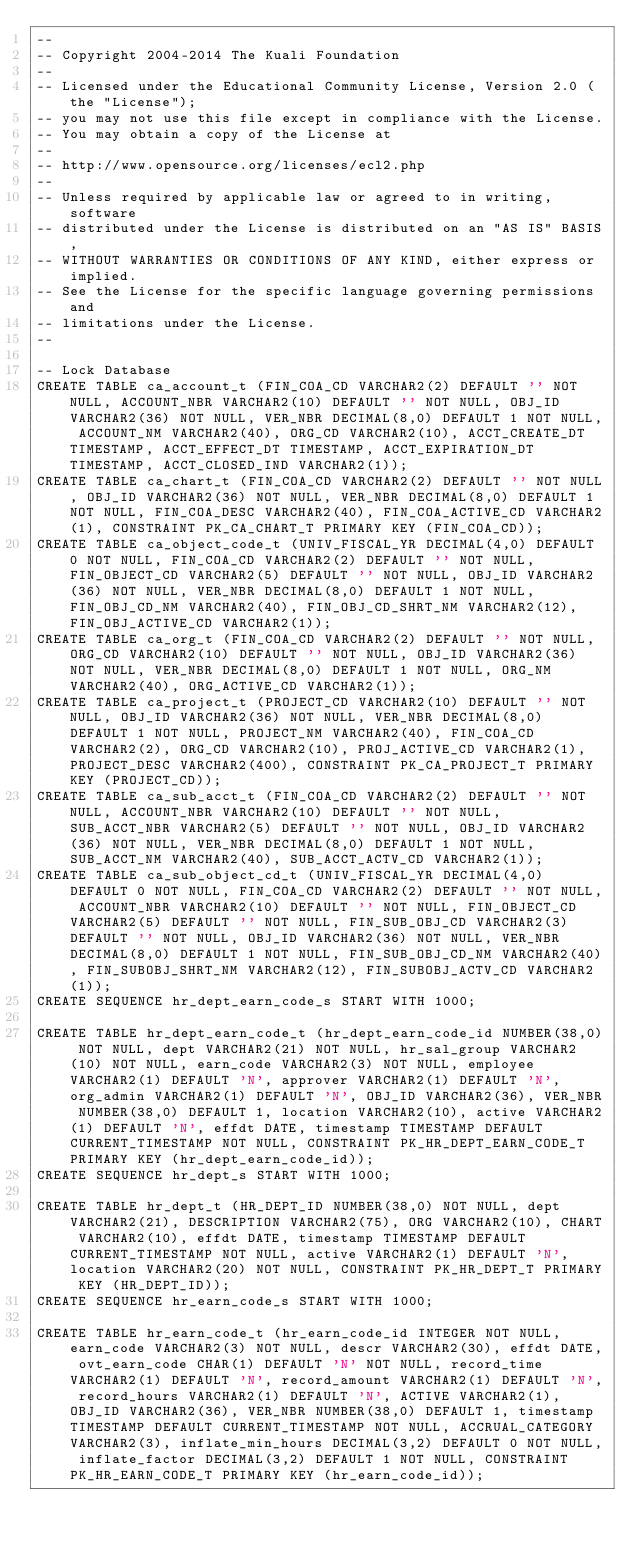<code> <loc_0><loc_0><loc_500><loc_500><_SQL_>--
-- Copyright 2004-2014 The Kuali Foundation
--
-- Licensed under the Educational Community License, Version 2.0 (the "License");
-- you may not use this file except in compliance with the License.
-- You may obtain a copy of the License at
--
-- http://www.opensource.org/licenses/ecl2.php
--
-- Unless required by applicable law or agreed to in writing, software
-- distributed under the License is distributed on an "AS IS" BASIS,
-- WITHOUT WARRANTIES OR CONDITIONS OF ANY KIND, either express or implied.
-- See the License for the specific language governing permissions and
-- limitations under the License.
--

-- Lock Database
CREATE TABLE ca_account_t (FIN_COA_CD VARCHAR2(2) DEFAULT '' NOT NULL, ACCOUNT_NBR VARCHAR2(10) DEFAULT '' NOT NULL, OBJ_ID VARCHAR2(36) NOT NULL, VER_NBR DECIMAL(8,0) DEFAULT 1 NOT NULL, ACCOUNT_NM VARCHAR2(40), ORG_CD VARCHAR2(10), ACCT_CREATE_DT TIMESTAMP, ACCT_EFFECT_DT TIMESTAMP, ACCT_EXPIRATION_DT TIMESTAMP, ACCT_CLOSED_IND VARCHAR2(1));
CREATE TABLE ca_chart_t (FIN_COA_CD VARCHAR2(2) DEFAULT '' NOT NULL, OBJ_ID VARCHAR2(36) NOT NULL, VER_NBR DECIMAL(8,0) DEFAULT 1 NOT NULL, FIN_COA_DESC VARCHAR2(40), FIN_COA_ACTIVE_CD VARCHAR2(1), CONSTRAINT PK_CA_CHART_T PRIMARY KEY (FIN_COA_CD));
CREATE TABLE ca_object_code_t (UNIV_FISCAL_YR DECIMAL(4,0) DEFAULT 0 NOT NULL, FIN_COA_CD VARCHAR2(2) DEFAULT '' NOT NULL, FIN_OBJECT_CD VARCHAR2(5) DEFAULT '' NOT NULL, OBJ_ID VARCHAR2(36) NOT NULL, VER_NBR DECIMAL(8,0) DEFAULT 1 NOT NULL, FIN_OBJ_CD_NM VARCHAR2(40), FIN_OBJ_CD_SHRT_NM VARCHAR2(12), FIN_OBJ_ACTIVE_CD VARCHAR2(1));
CREATE TABLE ca_org_t (FIN_COA_CD VARCHAR2(2) DEFAULT '' NOT NULL, ORG_CD VARCHAR2(10) DEFAULT '' NOT NULL, OBJ_ID VARCHAR2(36) NOT NULL, VER_NBR DECIMAL(8,0) DEFAULT 1 NOT NULL, ORG_NM VARCHAR2(40), ORG_ACTIVE_CD VARCHAR2(1));
CREATE TABLE ca_project_t (PROJECT_CD VARCHAR2(10) DEFAULT '' NOT NULL, OBJ_ID VARCHAR2(36) NOT NULL, VER_NBR DECIMAL(8,0) DEFAULT 1 NOT NULL, PROJECT_NM VARCHAR2(40), FIN_COA_CD VARCHAR2(2), ORG_CD VARCHAR2(10), PROJ_ACTIVE_CD VARCHAR2(1), PROJECT_DESC VARCHAR2(400), CONSTRAINT PK_CA_PROJECT_T PRIMARY KEY (PROJECT_CD));
CREATE TABLE ca_sub_acct_t (FIN_COA_CD VARCHAR2(2) DEFAULT '' NOT NULL, ACCOUNT_NBR VARCHAR2(10) DEFAULT '' NOT NULL, SUB_ACCT_NBR VARCHAR2(5) DEFAULT '' NOT NULL, OBJ_ID VARCHAR2(36) NOT NULL, VER_NBR DECIMAL(8,0) DEFAULT 1 NOT NULL, SUB_ACCT_NM VARCHAR2(40), SUB_ACCT_ACTV_CD VARCHAR2(1));
CREATE TABLE ca_sub_object_cd_t (UNIV_FISCAL_YR DECIMAL(4,0) DEFAULT 0 NOT NULL, FIN_COA_CD VARCHAR2(2) DEFAULT '' NOT NULL, ACCOUNT_NBR VARCHAR2(10) DEFAULT '' NOT NULL, FIN_OBJECT_CD VARCHAR2(5) DEFAULT '' NOT NULL, FIN_SUB_OBJ_CD VARCHAR2(3) DEFAULT '' NOT NULL, OBJ_ID VARCHAR2(36) NOT NULL, VER_NBR DECIMAL(8,0) DEFAULT 1 NOT NULL, FIN_SUB_OBJ_CD_NM VARCHAR2(40), FIN_SUBOBJ_SHRT_NM VARCHAR2(12), FIN_SUBOBJ_ACTV_CD VARCHAR2(1));
CREATE SEQUENCE hr_dept_earn_code_s START WITH 1000;

CREATE TABLE hr_dept_earn_code_t (hr_dept_earn_code_id NUMBER(38,0) NOT NULL, dept VARCHAR2(21) NOT NULL, hr_sal_group VARCHAR2(10) NOT NULL, earn_code VARCHAR2(3) NOT NULL, employee VARCHAR2(1) DEFAULT 'N', approver VARCHAR2(1) DEFAULT 'N', org_admin VARCHAR2(1) DEFAULT 'N', OBJ_ID VARCHAR2(36), VER_NBR NUMBER(38,0) DEFAULT 1, location VARCHAR2(10), active VARCHAR2(1) DEFAULT 'N', effdt DATE, timestamp TIMESTAMP DEFAULT CURRENT_TIMESTAMP NOT NULL, CONSTRAINT PK_HR_DEPT_EARN_CODE_T PRIMARY KEY (hr_dept_earn_code_id));
CREATE SEQUENCE hr_dept_s START WITH 1000;

CREATE TABLE hr_dept_t (HR_DEPT_ID NUMBER(38,0) NOT NULL, dept VARCHAR2(21), DESCRIPTION VARCHAR2(75), ORG VARCHAR2(10), CHART VARCHAR2(10), effdt DATE, timestamp TIMESTAMP DEFAULT CURRENT_TIMESTAMP NOT NULL, active VARCHAR2(1) DEFAULT 'N', location VARCHAR2(20) NOT NULL, CONSTRAINT PK_HR_DEPT_T PRIMARY KEY (HR_DEPT_ID));
CREATE SEQUENCE hr_earn_code_s START WITH 1000;

CREATE TABLE hr_earn_code_t (hr_earn_code_id INTEGER NOT NULL, earn_code VARCHAR2(3) NOT NULL, descr VARCHAR2(30), effdt DATE, ovt_earn_code CHAR(1) DEFAULT 'N' NOT NULL, record_time VARCHAR2(1) DEFAULT 'N', record_amount VARCHAR2(1) DEFAULT 'N', record_hours VARCHAR2(1) DEFAULT 'N', ACTIVE VARCHAR2(1), OBJ_ID VARCHAR2(36), VER_NBR NUMBER(38,0) DEFAULT 1, timestamp TIMESTAMP DEFAULT CURRENT_TIMESTAMP NOT NULL, ACCRUAL_CATEGORY VARCHAR2(3), inflate_min_hours DECIMAL(3,2) DEFAULT 0 NOT NULL, inflate_factor DECIMAL(3,2) DEFAULT 1 NOT NULL, CONSTRAINT PK_HR_EARN_CODE_T PRIMARY KEY (hr_earn_code_id));</code> 